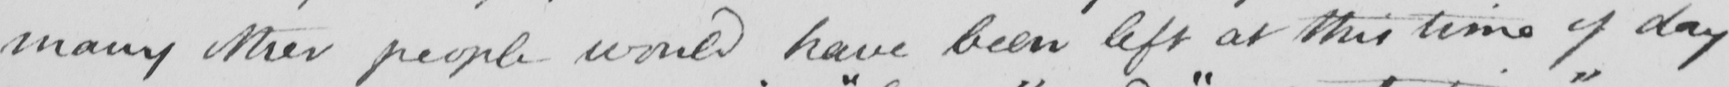What is written in this line of handwriting? many other people would have been left at this time of day 